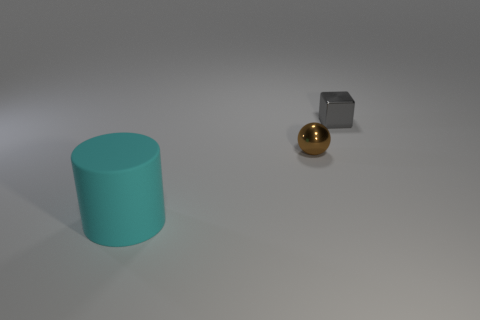Add 1 tiny brown metal spheres. How many objects exist? 4 Subtract 1 brown spheres. How many objects are left? 2 Subtract all blue metal cylinders. Subtract all small brown balls. How many objects are left? 2 Add 1 small gray cubes. How many small gray cubes are left? 2 Add 2 big blue matte cylinders. How many big blue matte cylinders exist? 2 